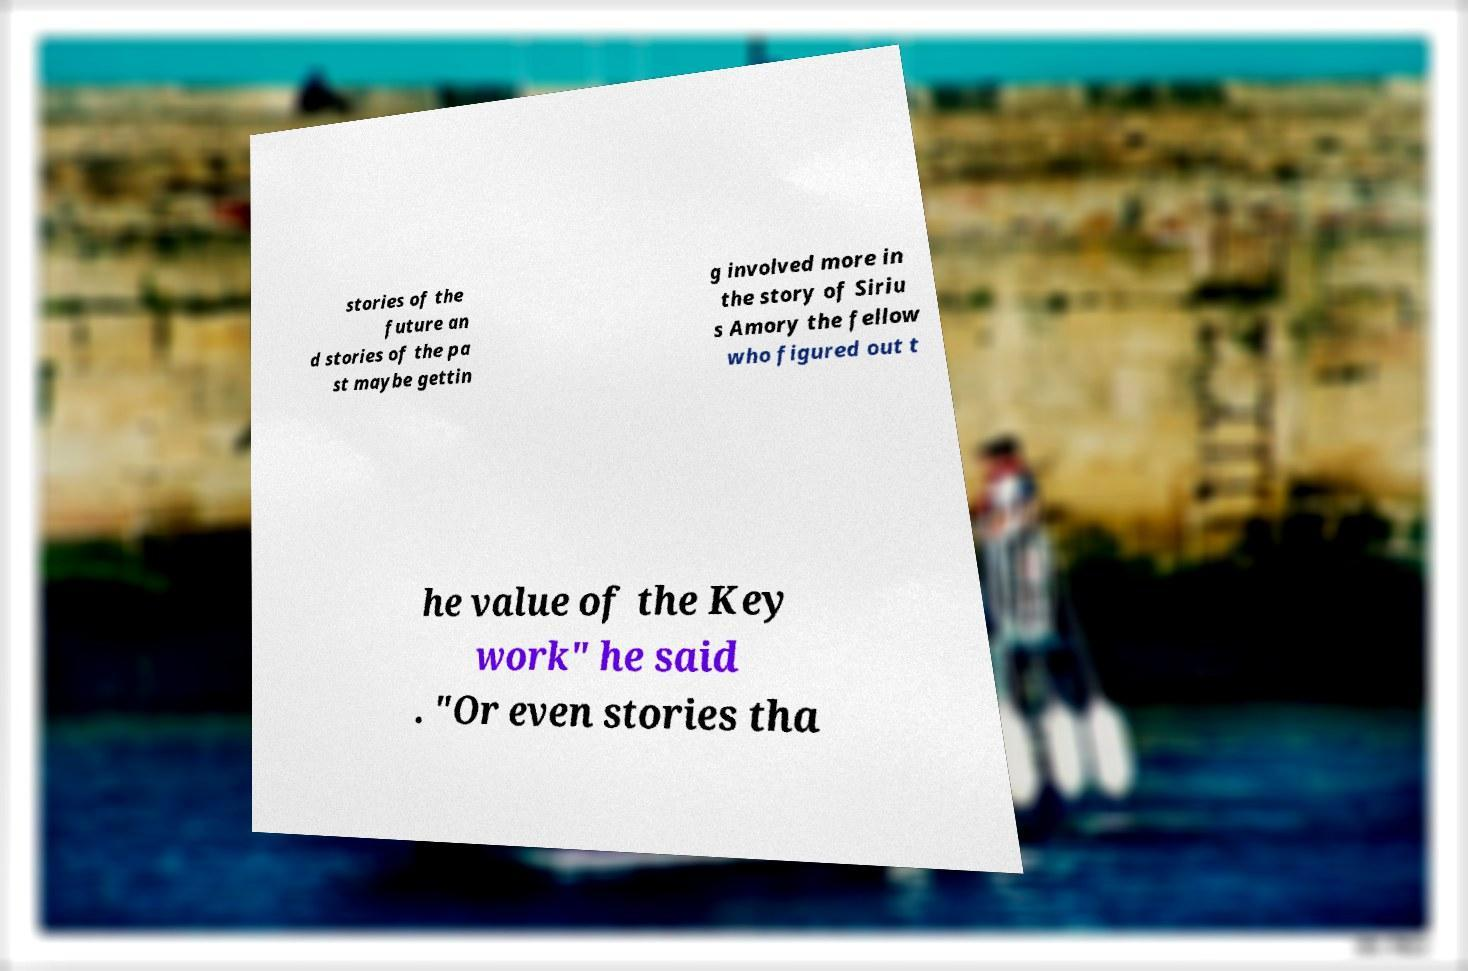Can you accurately transcribe the text from the provided image for me? stories of the future an d stories of the pa st maybe gettin g involved more in the story of Siriu s Amory the fellow who figured out t he value of the Key work" he said . "Or even stories tha 